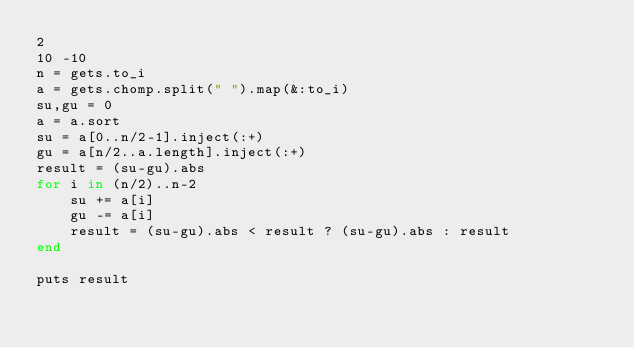<code> <loc_0><loc_0><loc_500><loc_500><_Ruby_>2
10 -10
n = gets.to_i
a = gets.chomp.split(" ").map(&:to_i)
su,gu = 0
a = a.sort
su = a[0..n/2-1].inject(:+)
gu = a[n/2..a.length].inject(:+)
result = (su-gu).abs
for i in (n/2)..n-2
	su += a[i]
	gu -= a[i]
	result = (su-gu).abs < result ? (su-gu).abs : result
end

puts result
</code> 